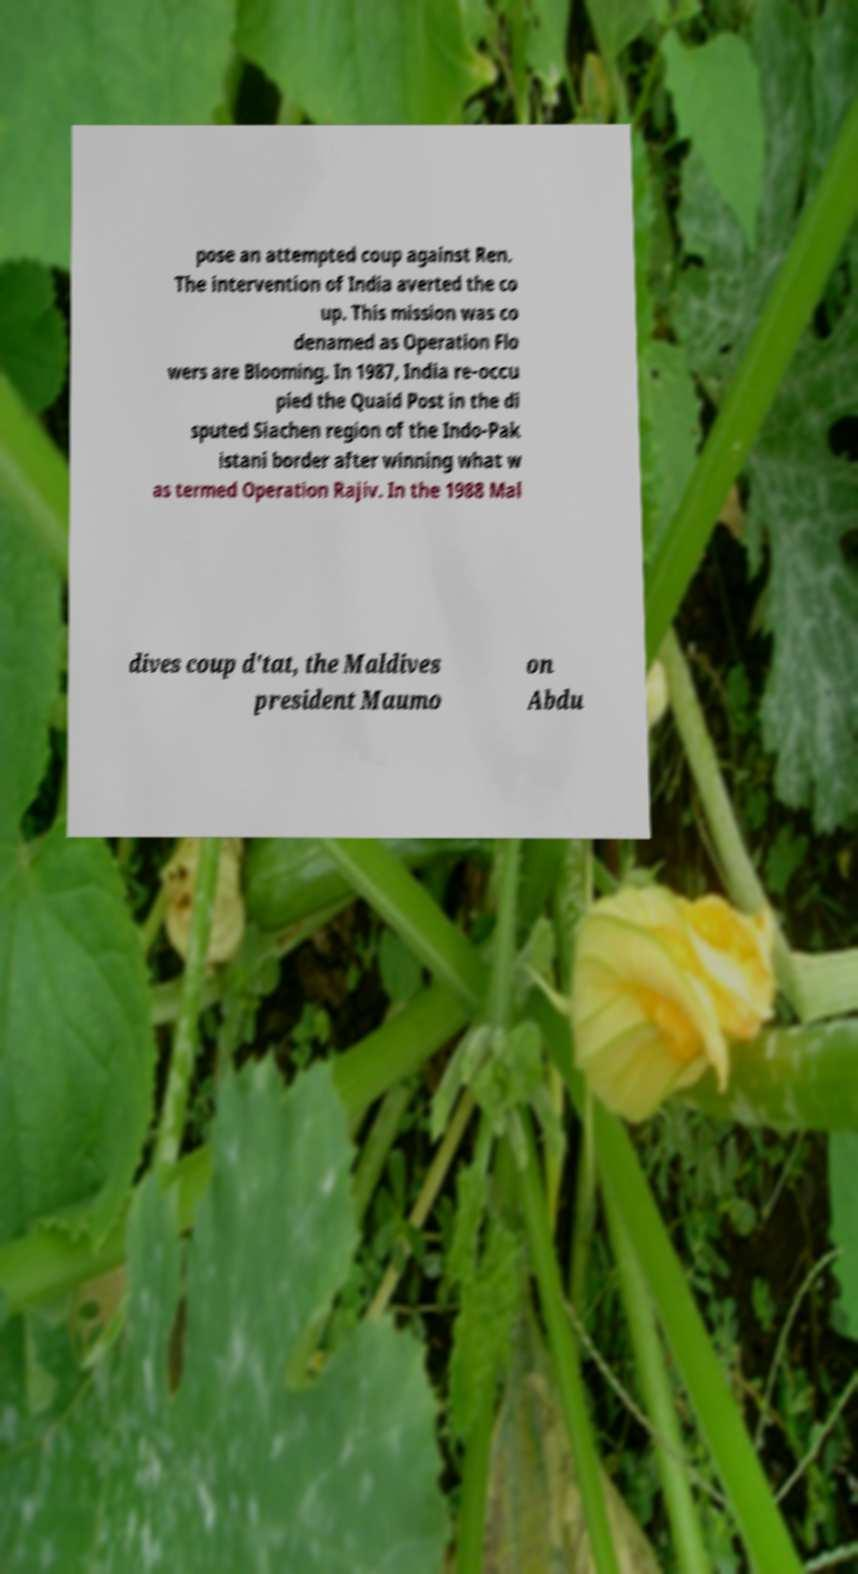Can you accurately transcribe the text from the provided image for me? pose an attempted coup against Ren. The intervention of India averted the co up. This mission was co denamed as Operation Flo wers are Blooming. In 1987, India re-occu pied the Quaid Post in the di sputed Siachen region of the Indo-Pak istani border after winning what w as termed Operation Rajiv. In the 1988 Mal dives coup d'tat, the Maldives president Maumo on Abdu 